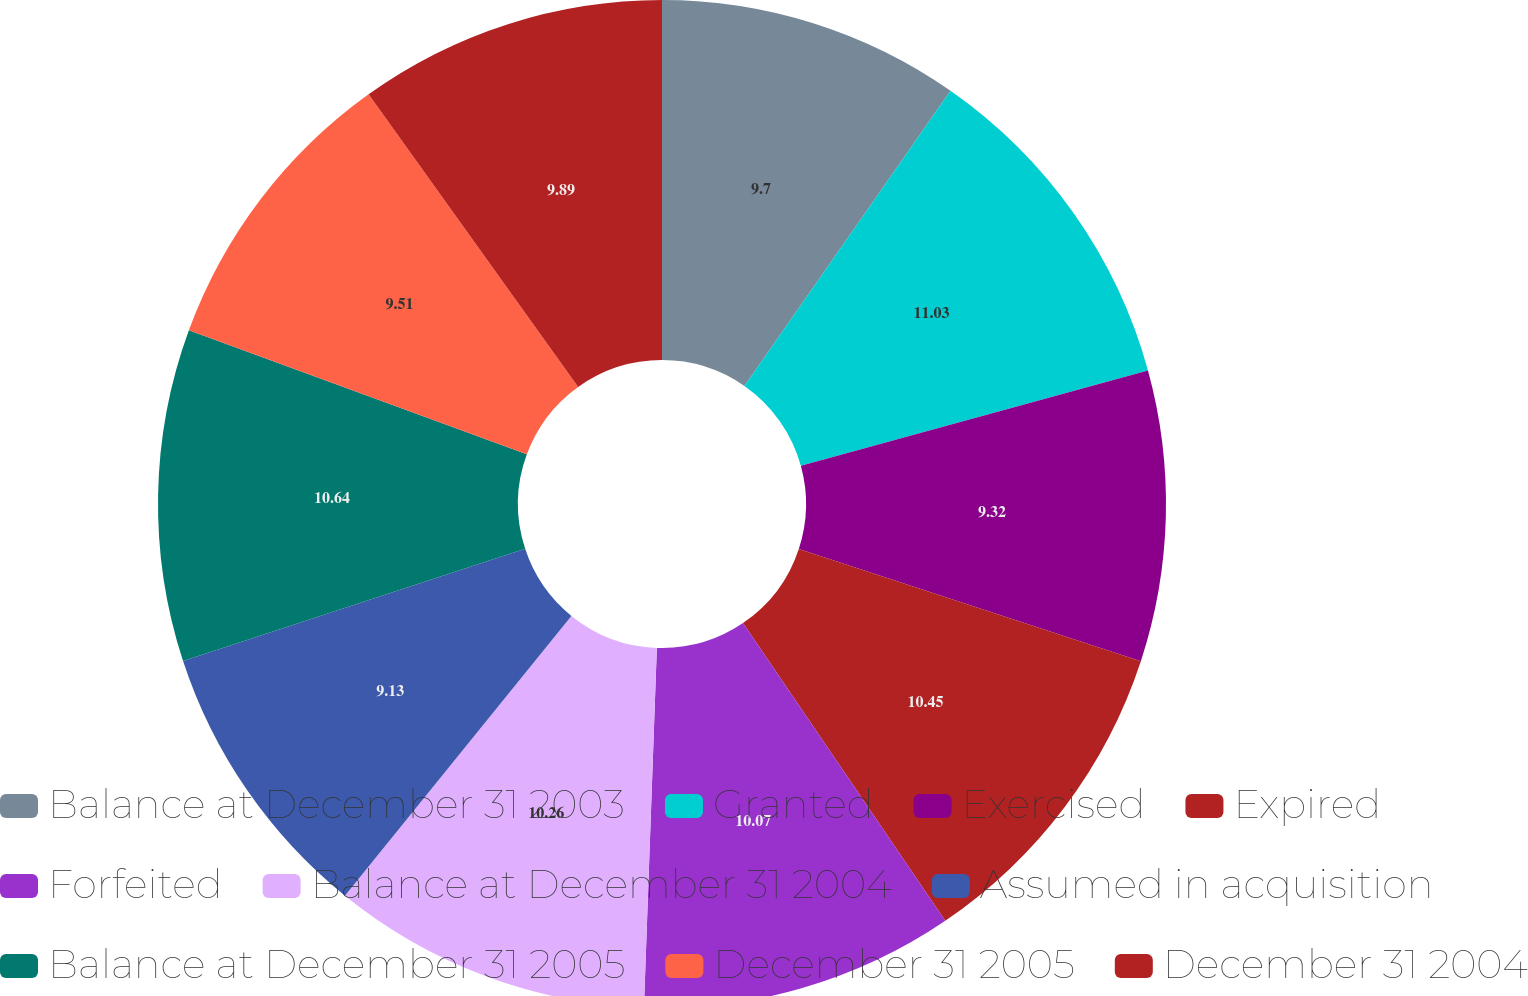<chart> <loc_0><loc_0><loc_500><loc_500><pie_chart><fcel>Balance at December 31 2003<fcel>Granted<fcel>Exercised<fcel>Expired<fcel>Forfeited<fcel>Balance at December 31 2004<fcel>Assumed in acquisition<fcel>Balance at December 31 2005<fcel>December 31 2005<fcel>December 31 2004<nl><fcel>9.7%<fcel>11.03%<fcel>9.32%<fcel>10.45%<fcel>10.07%<fcel>10.26%<fcel>9.13%<fcel>10.64%<fcel>9.51%<fcel>9.89%<nl></chart> 